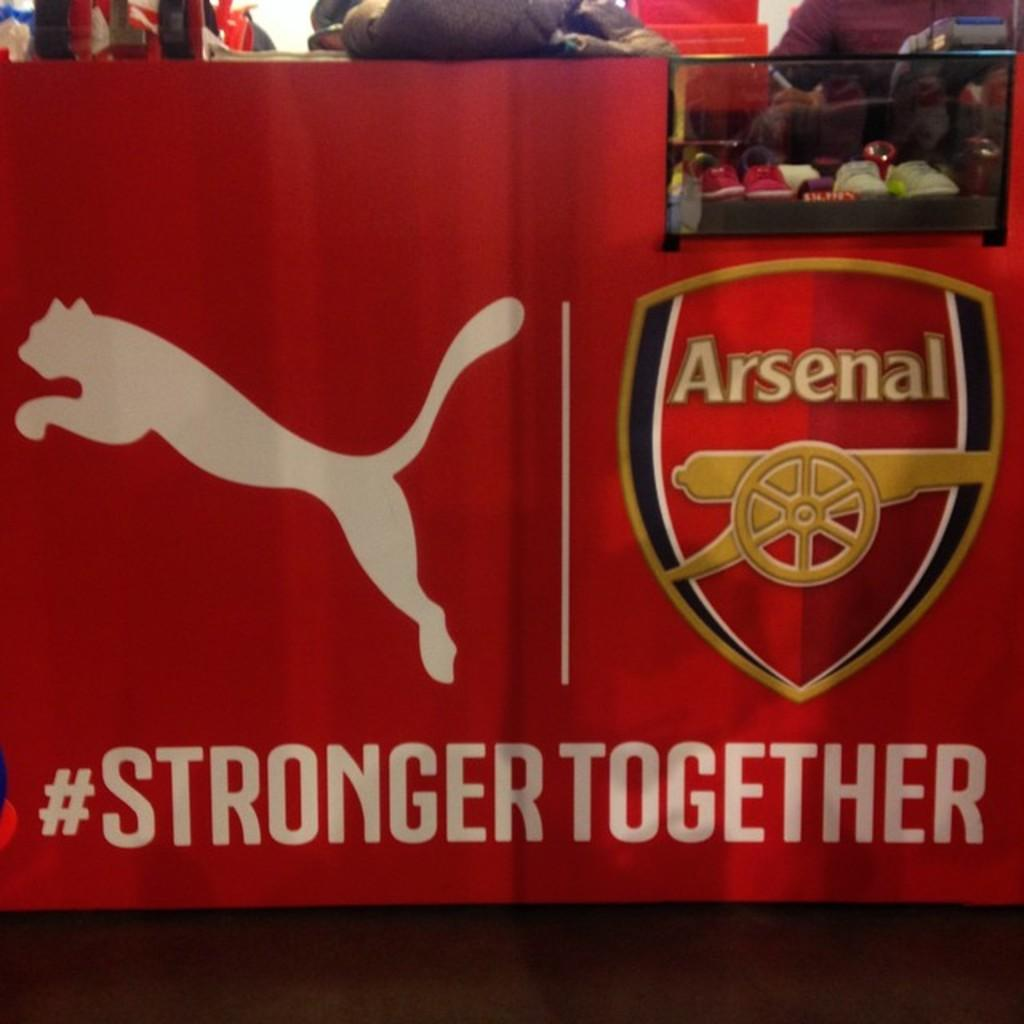<image>
Provide a brief description of the given image. People sit at a bar where on the sides there's a banner for Arsenal. 